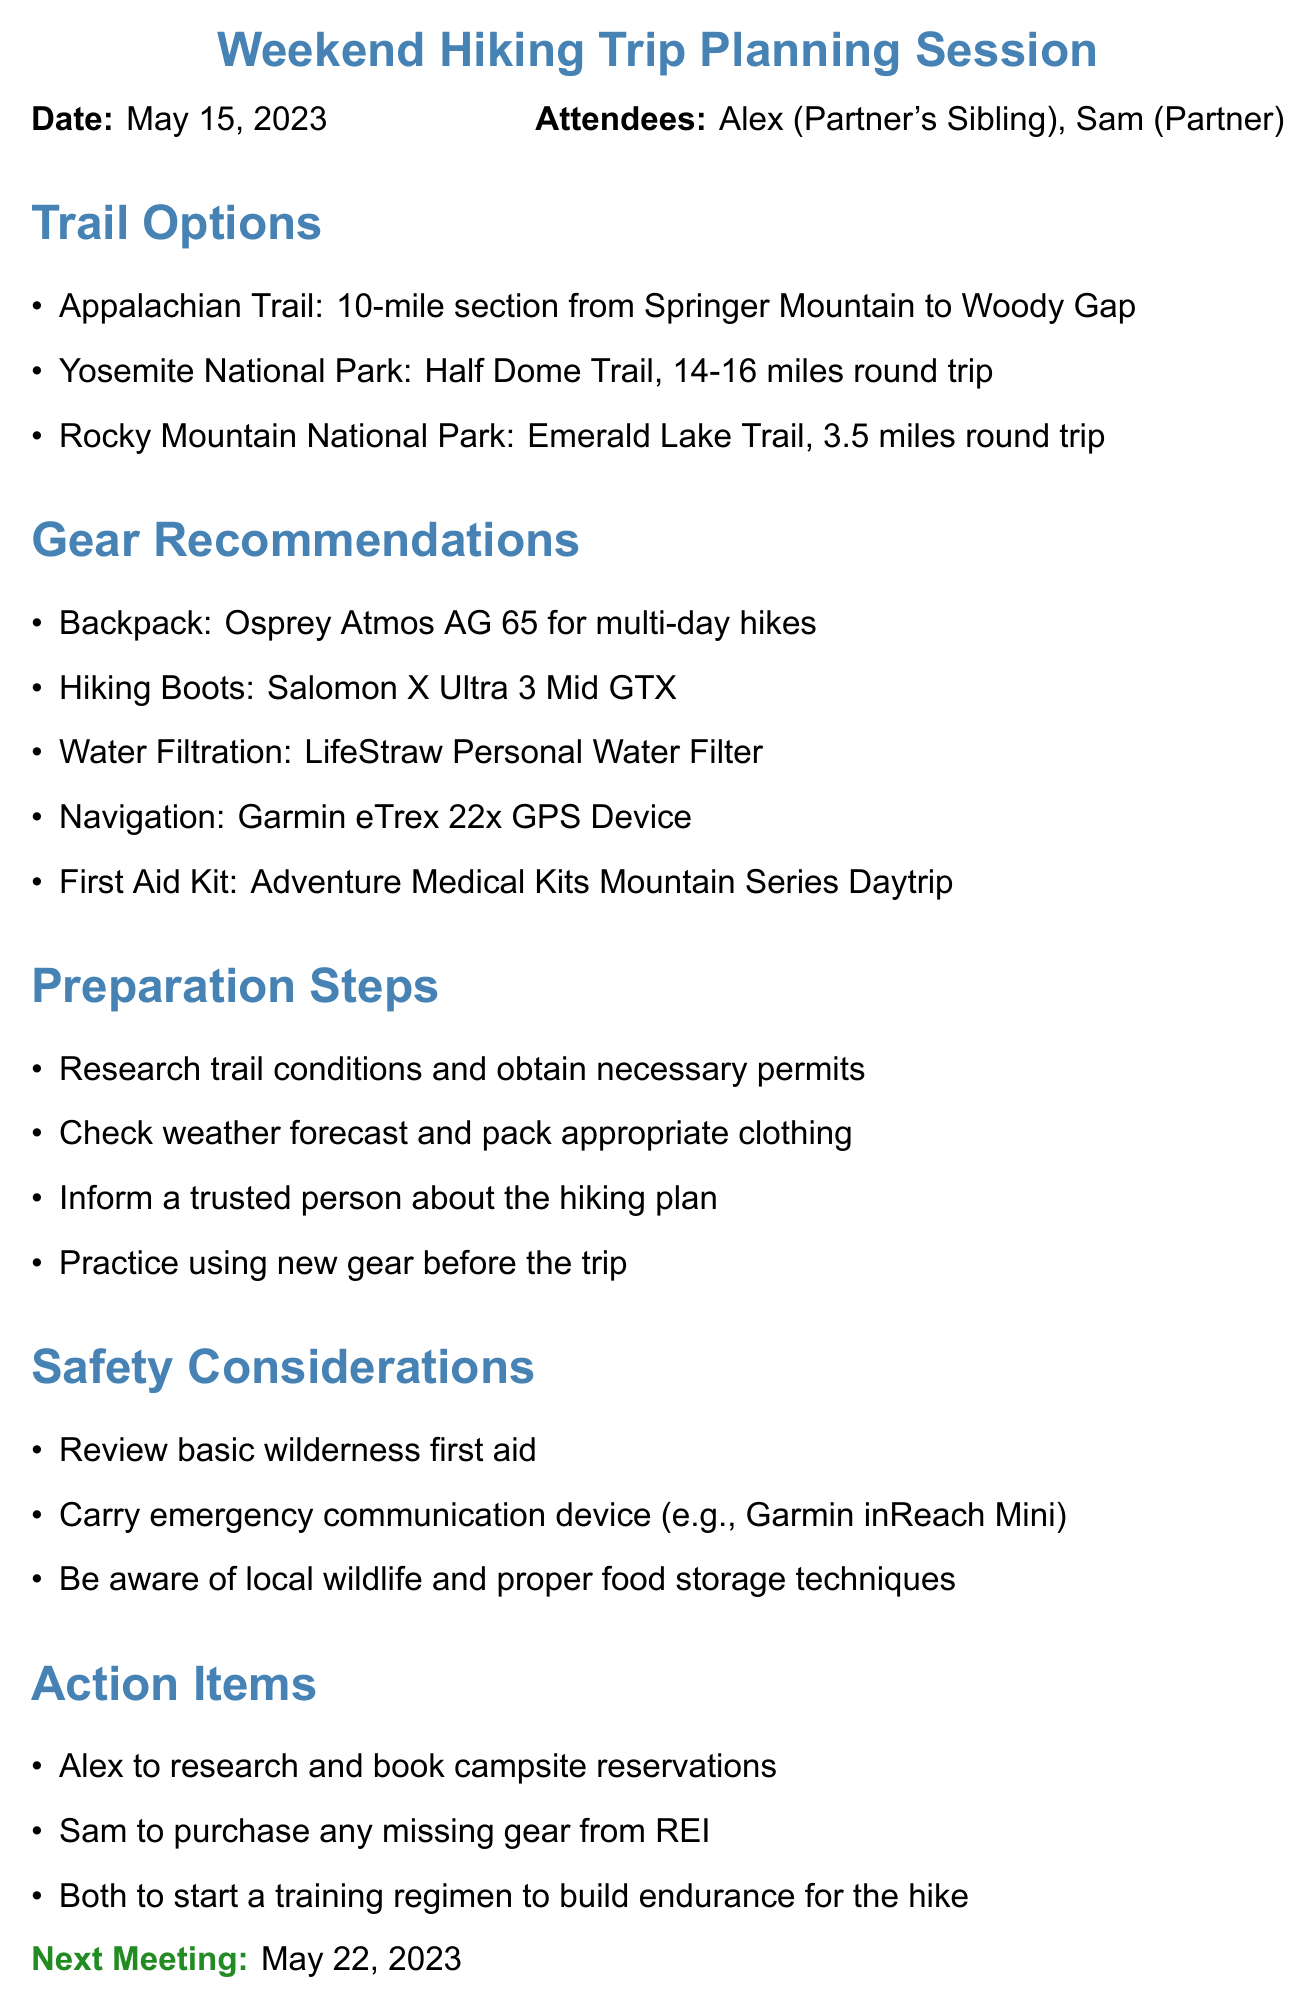What is the meeting title? The meeting title is explicitly stated in the document under the header.
Answer: Weekend Hiking Trip Planning Session What are the names of the attendees? The attendees are listed right after the date, specifying their roles.
Answer: Alex (Partner's Sibling), Sam (Partner) How many miles is the Half Dome Trail round trip? This information is found in the Trail Options section detailing the trail distance.
Answer: 14-16 miles What is the recommended backpack for multi-day hikes? The Gear Recommendations section specifies the backpack suitable for multi-day hikes.
Answer: Osprey Atmos AG 65 What is one of the preparation steps mentioned? Several preparation steps are listed, any of which can serve as an answer.
Answer: Research trail conditions and obtain necessary permits How many action items are listed? By counting the items under the Action Items section, we determine the number of tasks.
Answer: 3 What date is the next meeting scheduled for? The next meeting date appears at the end of the document.
Answer: May 22, 2023 What is one safety consideration mentioned? Safety considerations are explicitly stated in their dedicated section.
Answer: Review basic wilderness first aid What type of GPS device is recommended for navigation? The Gear Recommendations section directly mentions the type of GPS device.
Answer: Garmin eTrex 22x GPS Device 